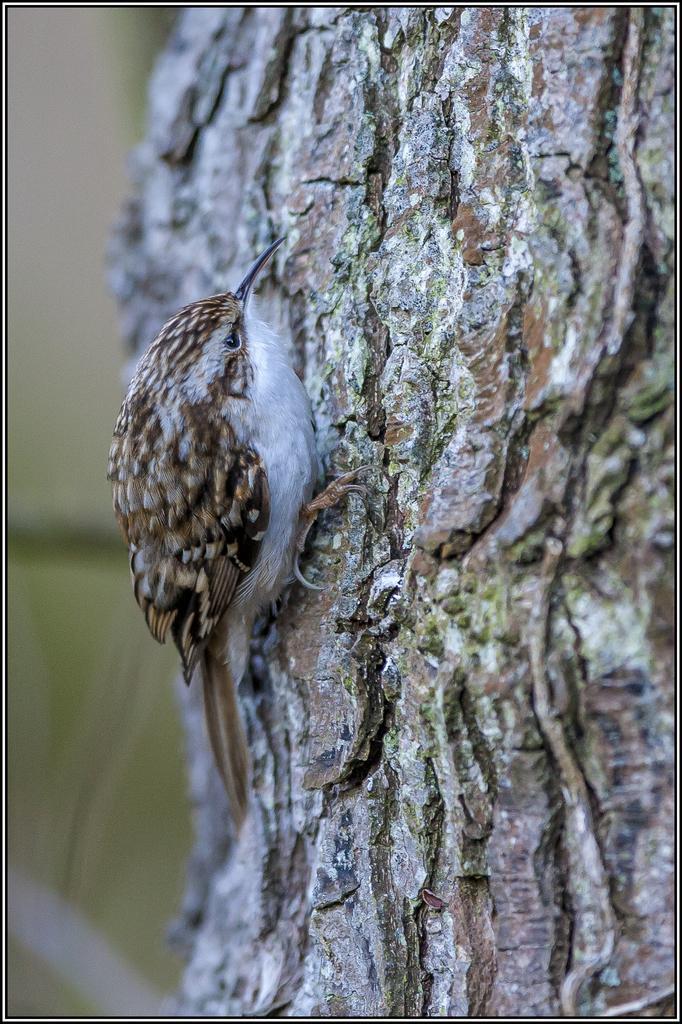How would you summarize this image in a sentence or two? In this picture I can see a bird on the tree bark and I can see blurry background. 